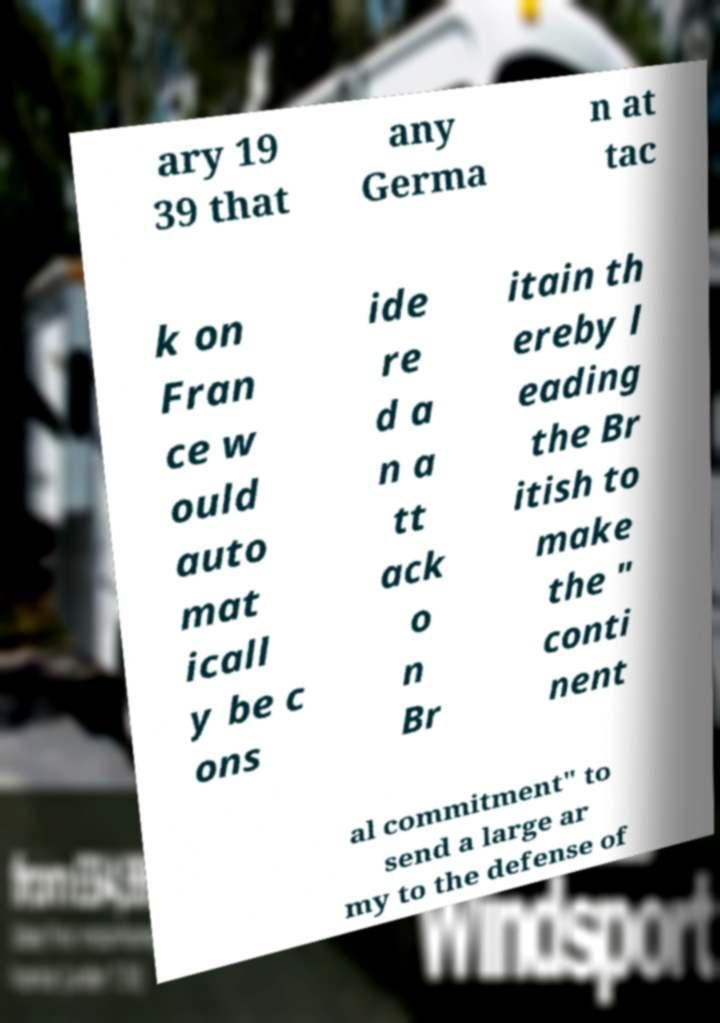Can you read and provide the text displayed in the image?This photo seems to have some interesting text. Can you extract and type it out for me? ary 19 39 that any Germa n at tac k on Fran ce w ould auto mat icall y be c ons ide re d a n a tt ack o n Br itain th ereby l eading the Br itish to make the " conti nent al commitment" to send a large ar my to the defense of 